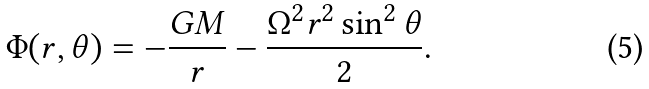Convert formula to latex. <formula><loc_0><loc_0><loc_500><loc_500>\Phi ( r , \theta ) = - \frac { G M } { r } - \frac { \Omega ^ { 2 } r ^ { 2 } \sin ^ { 2 } \theta } { 2 } .</formula> 